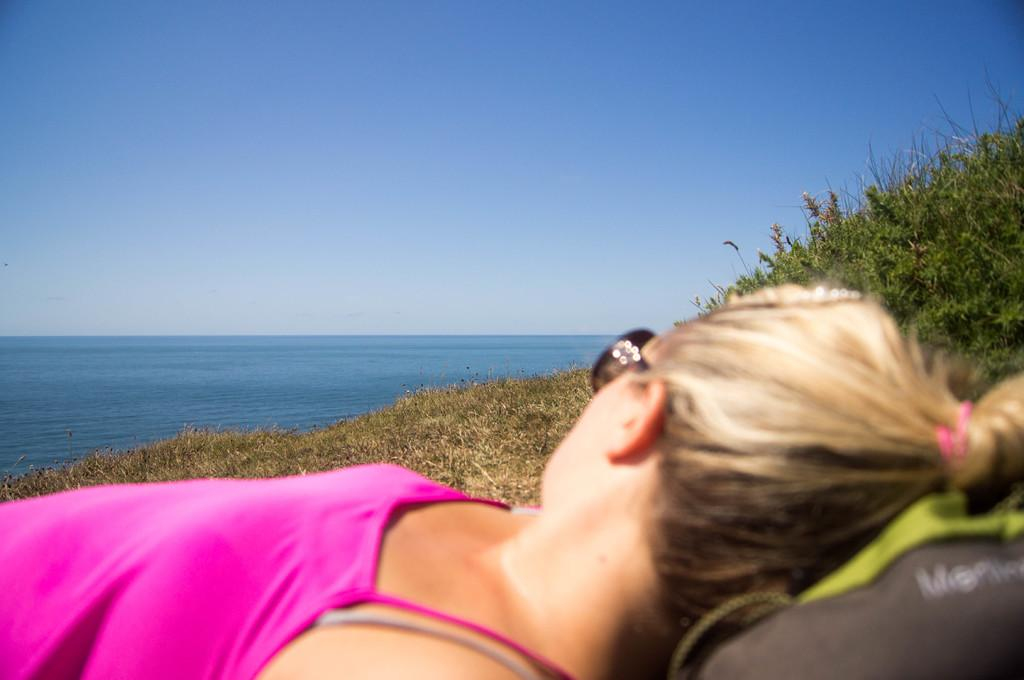Who is the main subject in the image? There is a lady in the image. What is the lady's position in the image? The lady is lying on a grassland. What can be seen in the background of the image? There is a sea and the sky visible in the background of the image. What type of popcorn is being served to the geese in the image? There is no popcorn or geese present in the image. What color is the sky in the image? The color of the sky is not mentioned in the provided facts, so we cannot determine its color from the image. 